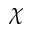Convert formula to latex. <formula><loc_0><loc_0><loc_500><loc_500>\chi</formula> 